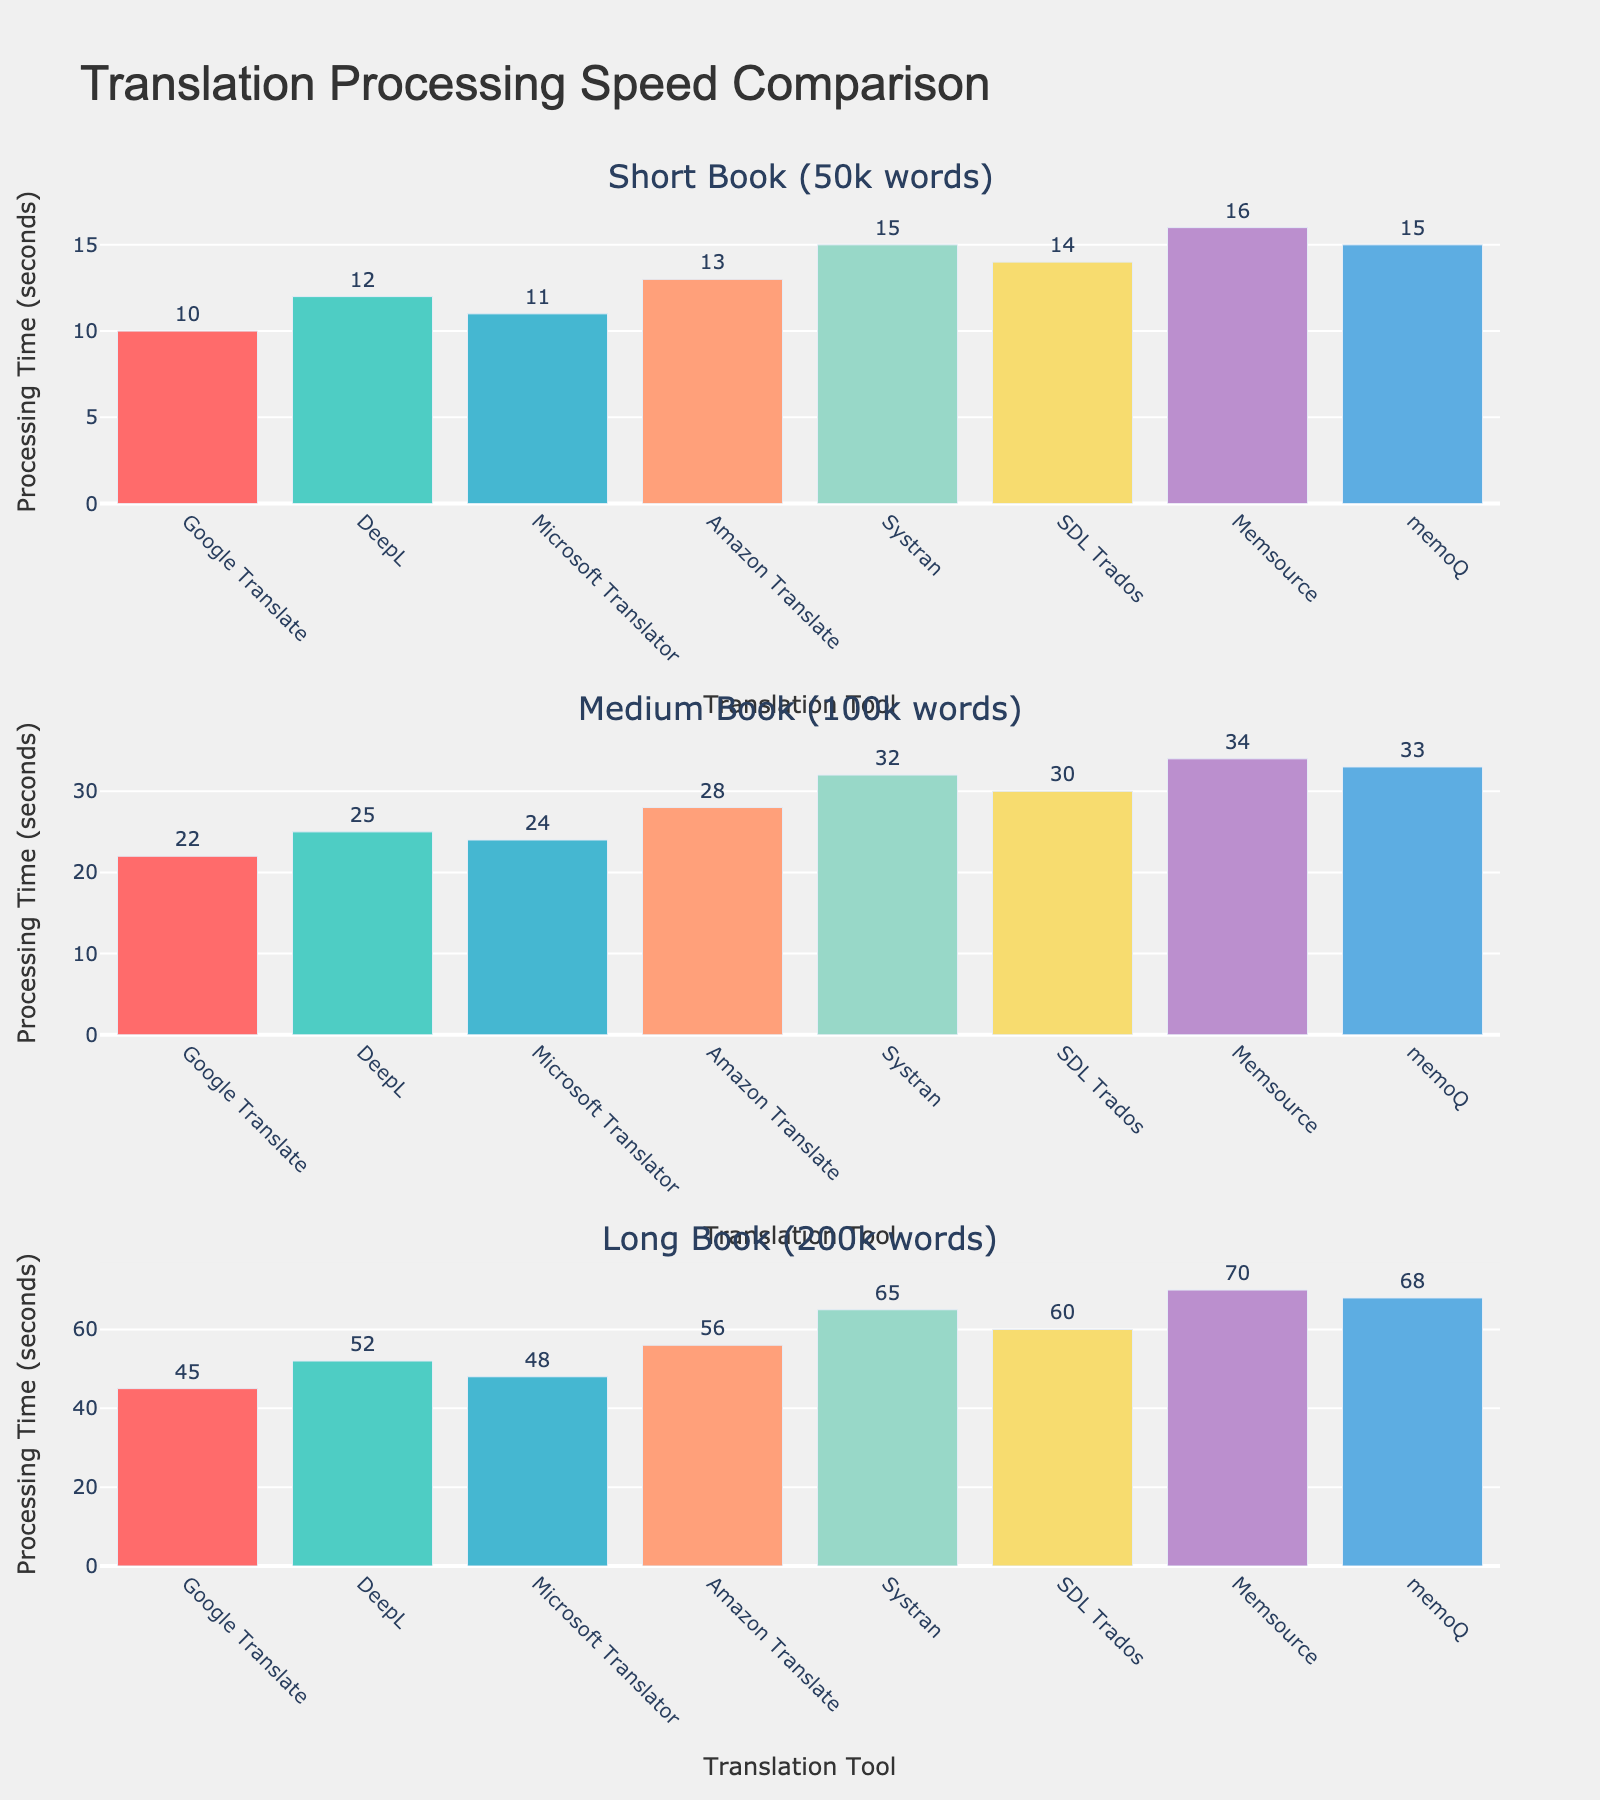Which translation tool is the fastest for translating a short book? By observing the first subplot titled "Short Book (50k words)," we see that Google Translate has the lowest bar, indicating the shortest processing time of 10 seconds.
Answer: Google Translate Which tool takes the longest time to process a medium book? In the second subplot titled "Medium Book (100k words)," the tallest bar corresponds to Memsource, which takes 34 seconds, making it the slowest.
Answer: Memsource What is Systran's processing time for a long book? Look at the bar for Systran in the third subplot titled "Long Book (200k words)," which shows a processing time of 65 seconds.
Answer: 65 seconds How much longer does it take Amazon Translate to process a long book compared to a short book? By referring to Amazon Translate's bars in both the "Short Book" (13 seconds) and "Long Book" (56 seconds) subplots, the difference is 56 - 13 = 43 seconds.
Answer: 43 seconds Which translation tool shows the most consistent processing times across different book lengths? By comparing the relative heights of the bars for each tool across all three subplots, Google Translate shows the least variation between bars (10, 22, and 45 seconds).
Answer: Google Translate If you sum the processing times of DeepL for all three book lengths, what is the total? Sum DeepL's values from all subplots: 12 (short) + 25 (medium) + 52 (long) = 89 seconds.
Answer: 89 seconds Which tools have the same processing time for a short book? The first subplot shows that both Systran and memoQ have processing times of 15 seconds each.
Answer: Systran and memoQ Does any tool take exactly twice as long to process a long book as it does to process a short book? Compare each tool's times across subplots. For SDL Trados, the processing times are 14 seconds (short) and 60 seconds (long). 60 seconds is not exactly twice 14 seconds. None fit this criterion exactly.
Answer: None How much faster is Google Translate compared to Microsoft Translator for a medium book? For a medium book, Google Translate takes 22 seconds, and Microsoft Translator takes 24 seconds. The difference is 24 - 22 = 2 seconds.
Answer: 2 seconds What is the average processing time for a long book across all translation tools? Sum the processing times from the "Long Book" subplot and divide by the number of tools. Total is 45 + 52 + 48 + 56 + 65 + 60 + 70 + 68 = 464. The number of tools is 8. So, average is 464 / 8 = 58 seconds.
Answer: 58 seconds 